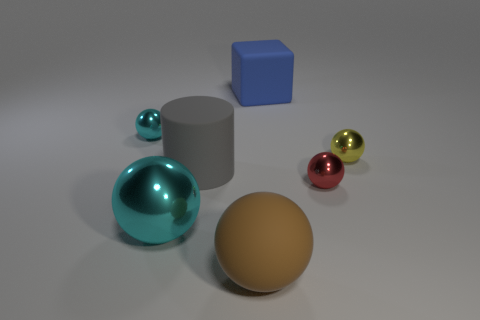Subtract all red cylinders. How many cyan balls are left? 2 Subtract all big matte spheres. How many spheres are left? 4 Add 3 big blue matte blocks. How many objects exist? 10 Subtract all brown spheres. How many spheres are left? 4 Subtract 2 spheres. How many spheres are left? 3 Subtract all gray spheres. Subtract all gray cylinders. How many spheres are left? 5 Subtract all cylinders. How many objects are left? 6 Add 5 big brown rubber balls. How many big brown rubber balls are left? 6 Add 7 large metallic objects. How many large metallic objects exist? 8 Subtract 0 green spheres. How many objects are left? 7 